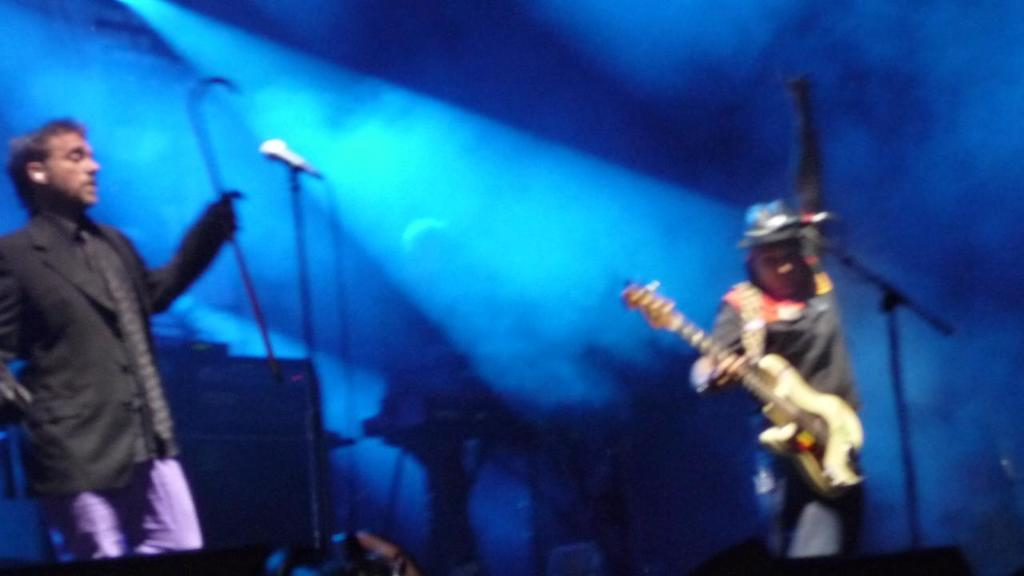What is the man on the left side of the image holding? The man on the left side of the image is holding a guitar. What is the man on the right side of the image holding? The man on the right side of the image is holding a stick in his hand. How many microphones are visible in the image? There are two microphones visible in the image. What time of day is it in the image, and how many cars can be seen? The time of day cannot be determined from the image, and there are no cars visible in the image. 